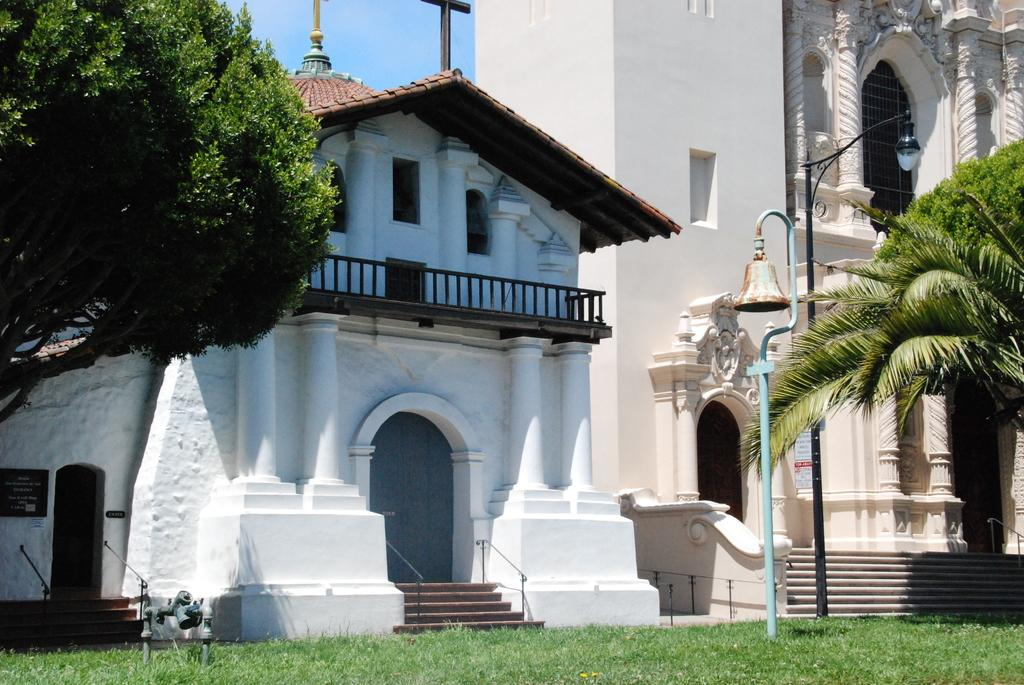What type of structures can be seen in the image? There are buildings in the image. What type of vegetation is visible in the image? There is grass visible in the image. What type of animals can be seen in the image? There are birds in the image. What type of objects are attached to the poles in the image? There are poles with a bell and light in the image. What type of natural elements can be seen in the image? There are trees in the image. What part of the natural environment is visible in the image? The sky is visible in the image. What type of plough is being used by the slave in the image? There is no plough or slave present in the image. What type of hammer is being used by the person in the image? There is no hammer or person using a hammer present in the image. 